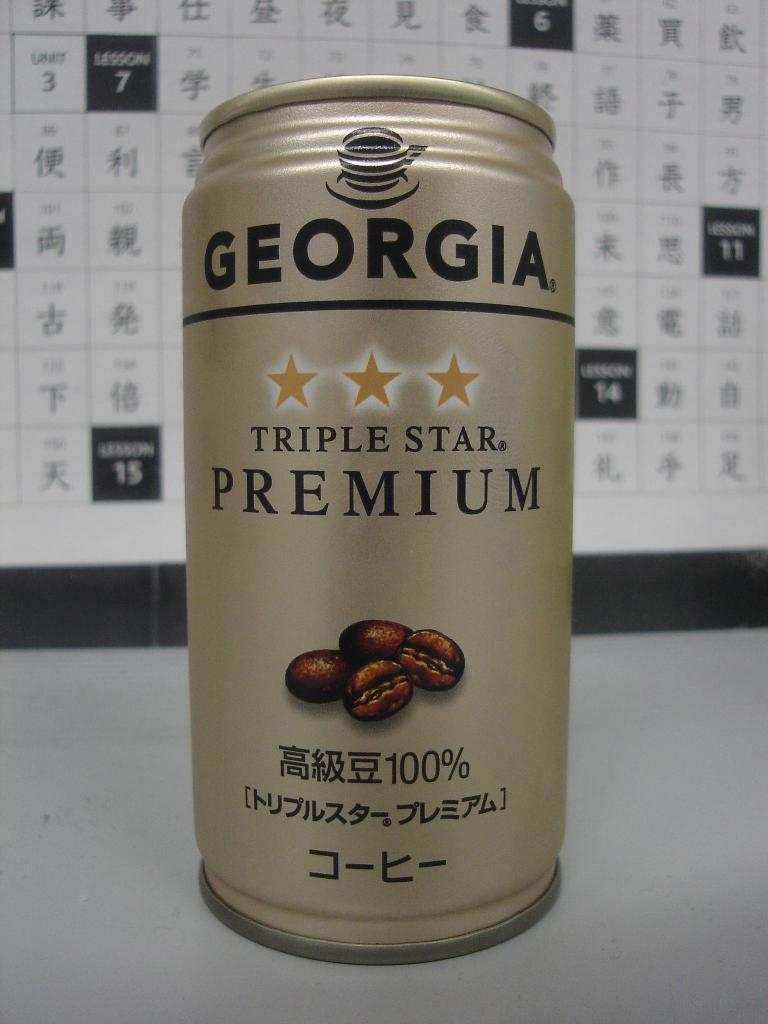<image>
Describe the image concisely. The coffee drink is called Georgia Triple Star Premium. 